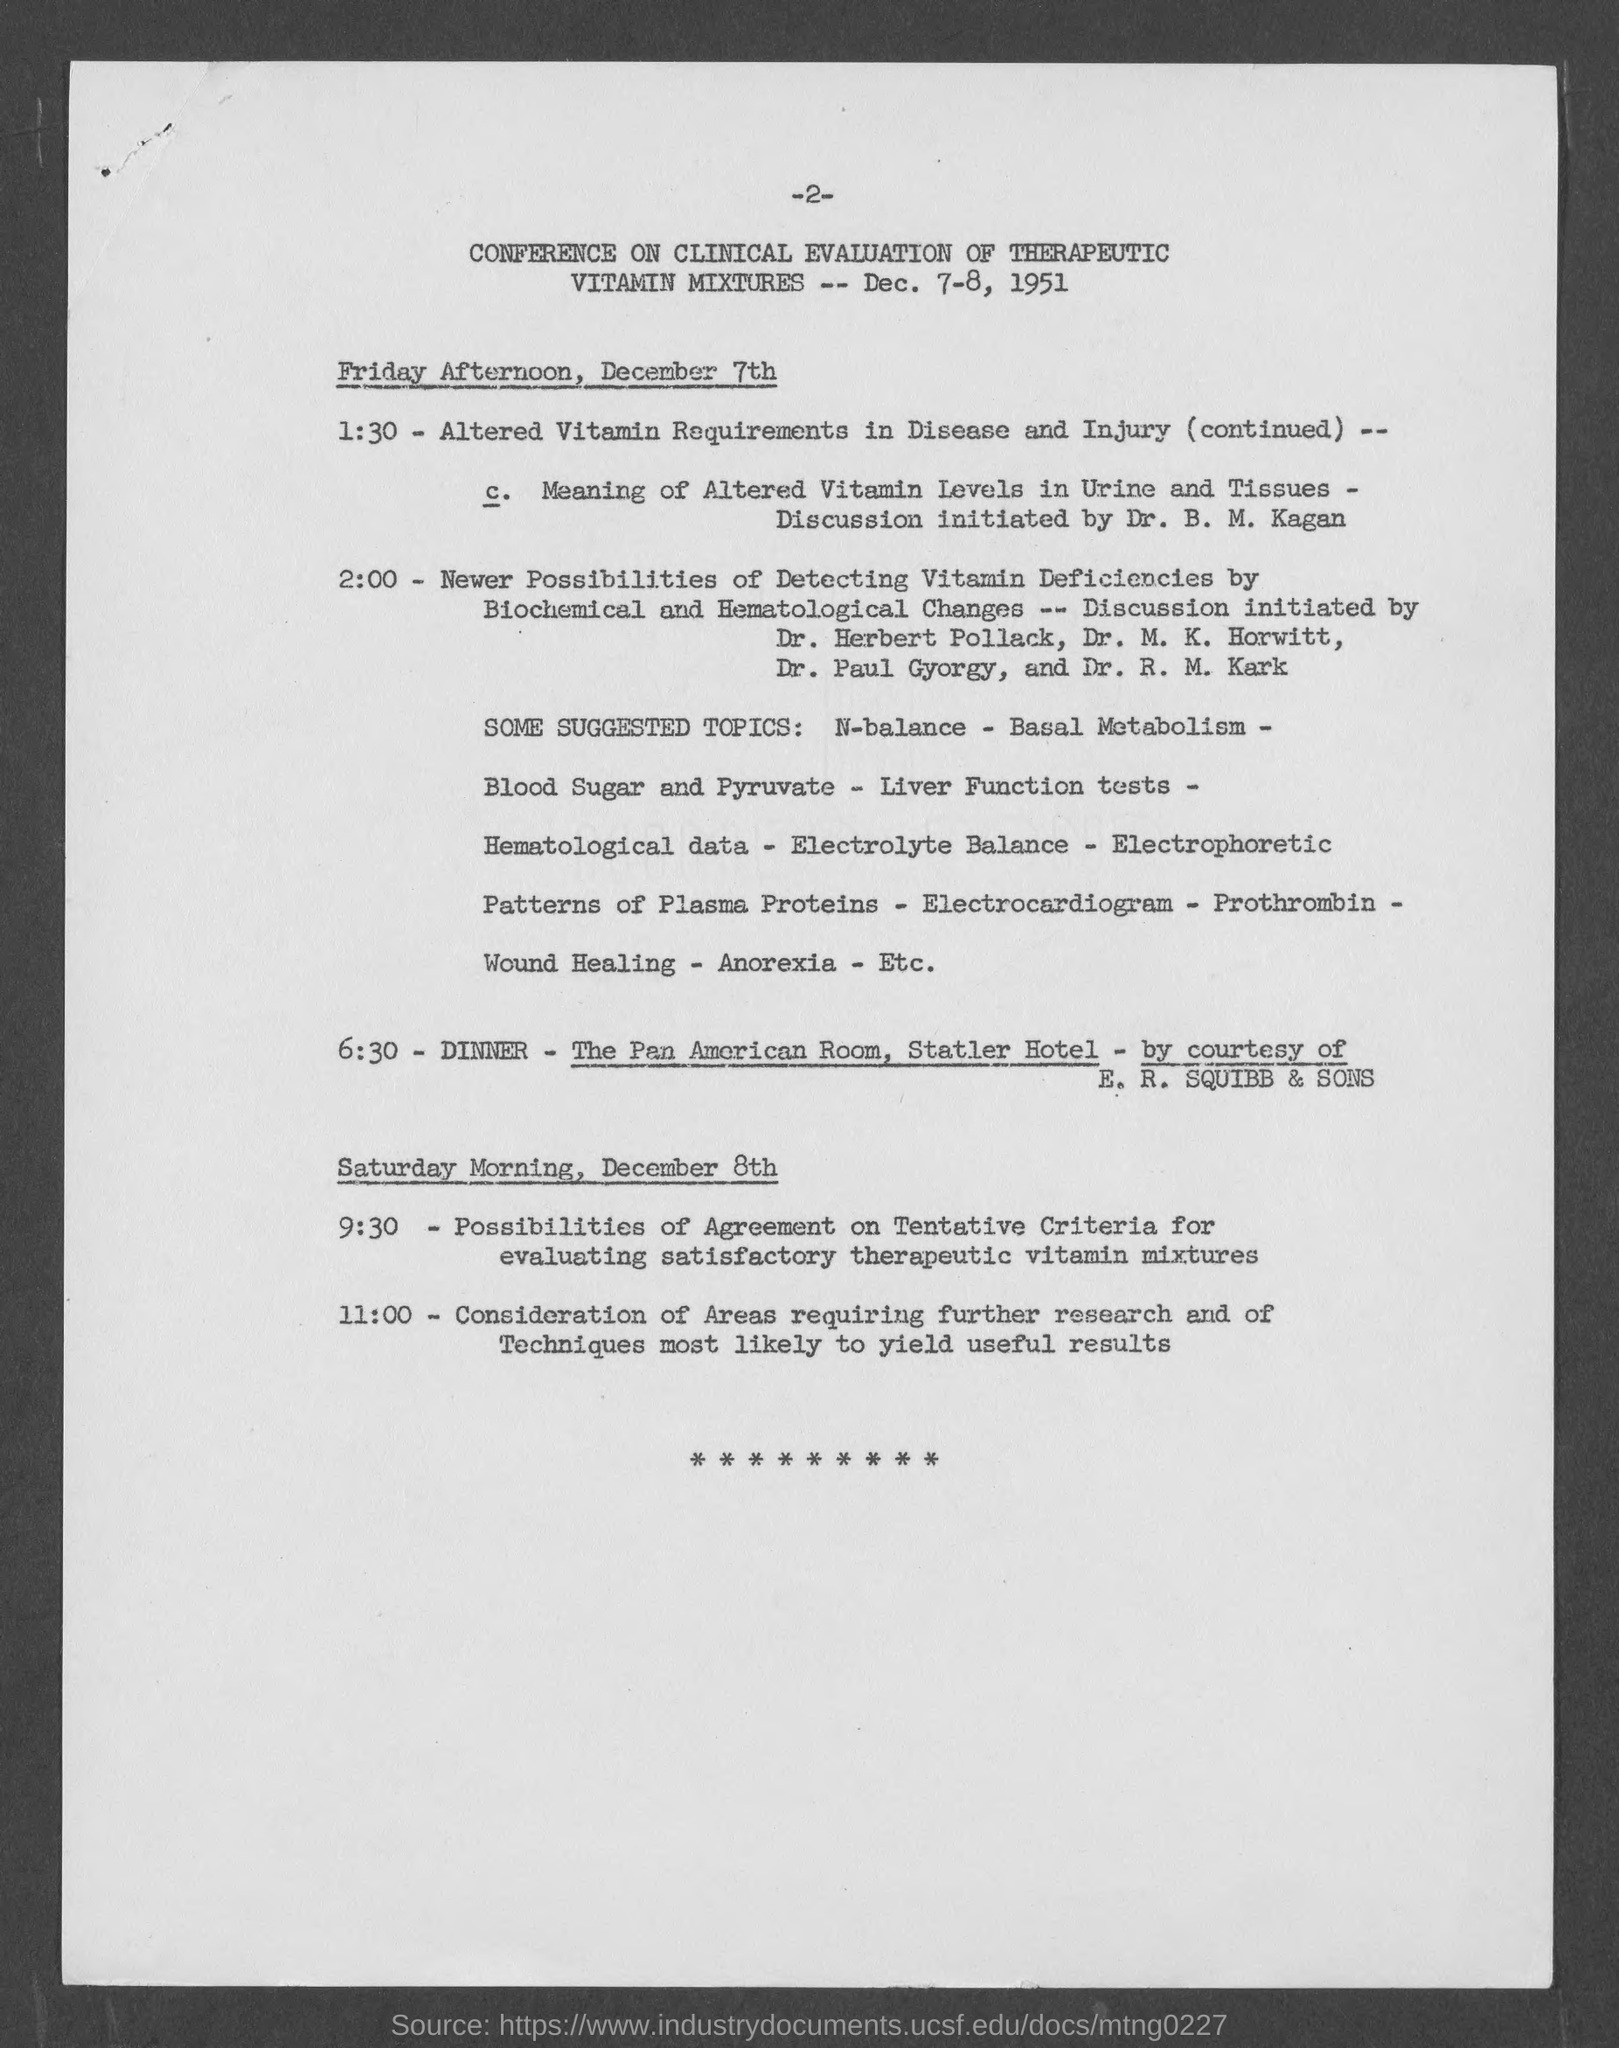Specify some key components in this picture. The conference is scheduled to be held on December 7th and 8th, 1951. The dinner will be held in the Pan American Room of the Statler Hotel. The dinner is being hosted by E. R. SQUIBB & SONS. The page number on this document is -2-. The conference is focused on the clinical evaluation of therapeutic vitamin mixtures. 